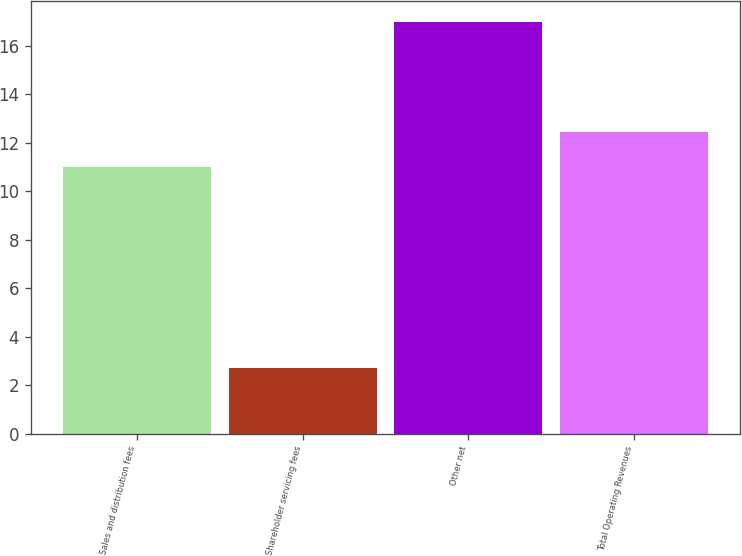Convert chart to OTSL. <chart><loc_0><loc_0><loc_500><loc_500><bar_chart><fcel>Sales and distribution fees<fcel>Shareholder servicing fees<fcel>Other net<fcel>Total Operating Revenues<nl><fcel>11<fcel>2.69<fcel>17<fcel>12.43<nl></chart> 